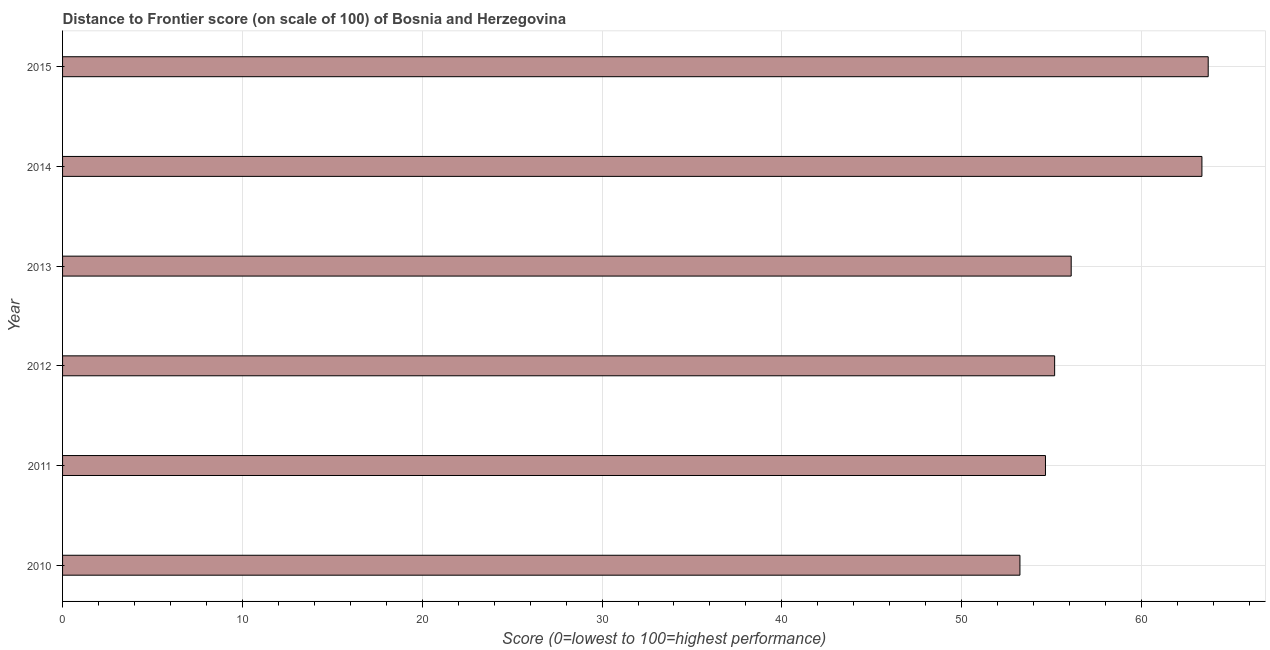Does the graph contain grids?
Make the answer very short. Yes. What is the title of the graph?
Offer a terse response. Distance to Frontier score (on scale of 100) of Bosnia and Herzegovina. What is the label or title of the X-axis?
Your answer should be compact. Score (0=lowest to 100=highest performance). What is the distance to frontier score in 2011?
Your answer should be compact. 54.66. Across all years, what is the maximum distance to frontier score?
Provide a succinct answer. 63.71. Across all years, what is the minimum distance to frontier score?
Provide a short and direct response. 53.24. In which year was the distance to frontier score maximum?
Offer a terse response. 2015. What is the sum of the distance to frontier score?
Keep it short and to the point. 346.23. What is the difference between the distance to frontier score in 2010 and 2015?
Your response must be concise. -10.47. What is the average distance to frontier score per year?
Your response must be concise. 57.7. What is the median distance to frontier score?
Give a very brief answer. 55.63. Do a majority of the years between 2014 and 2011 (inclusive) have distance to frontier score greater than 32 ?
Offer a very short reply. Yes. What is the ratio of the distance to frontier score in 2012 to that in 2015?
Your answer should be very brief. 0.87. Is the difference between the distance to frontier score in 2011 and 2013 greater than the difference between any two years?
Give a very brief answer. No. What is the difference between the highest and the lowest distance to frontier score?
Ensure brevity in your answer.  10.47. Are all the bars in the graph horizontal?
Your answer should be very brief. Yes. How many years are there in the graph?
Provide a short and direct response. 6. What is the Score (0=lowest to 100=highest performance) of 2010?
Provide a succinct answer. 53.24. What is the Score (0=lowest to 100=highest performance) in 2011?
Provide a short and direct response. 54.66. What is the Score (0=lowest to 100=highest performance) in 2012?
Give a very brief answer. 55.17. What is the Score (0=lowest to 100=highest performance) in 2013?
Keep it short and to the point. 56.09. What is the Score (0=lowest to 100=highest performance) in 2014?
Give a very brief answer. 63.36. What is the Score (0=lowest to 100=highest performance) of 2015?
Make the answer very short. 63.71. What is the difference between the Score (0=lowest to 100=highest performance) in 2010 and 2011?
Give a very brief answer. -1.42. What is the difference between the Score (0=lowest to 100=highest performance) in 2010 and 2012?
Keep it short and to the point. -1.93. What is the difference between the Score (0=lowest to 100=highest performance) in 2010 and 2013?
Keep it short and to the point. -2.85. What is the difference between the Score (0=lowest to 100=highest performance) in 2010 and 2014?
Offer a very short reply. -10.12. What is the difference between the Score (0=lowest to 100=highest performance) in 2010 and 2015?
Your answer should be very brief. -10.47. What is the difference between the Score (0=lowest to 100=highest performance) in 2011 and 2012?
Ensure brevity in your answer.  -0.51. What is the difference between the Score (0=lowest to 100=highest performance) in 2011 and 2013?
Keep it short and to the point. -1.43. What is the difference between the Score (0=lowest to 100=highest performance) in 2011 and 2014?
Your answer should be compact. -8.7. What is the difference between the Score (0=lowest to 100=highest performance) in 2011 and 2015?
Provide a succinct answer. -9.05. What is the difference between the Score (0=lowest to 100=highest performance) in 2012 and 2013?
Offer a very short reply. -0.92. What is the difference between the Score (0=lowest to 100=highest performance) in 2012 and 2014?
Your answer should be very brief. -8.19. What is the difference between the Score (0=lowest to 100=highest performance) in 2012 and 2015?
Your answer should be very brief. -8.54. What is the difference between the Score (0=lowest to 100=highest performance) in 2013 and 2014?
Provide a short and direct response. -7.27. What is the difference between the Score (0=lowest to 100=highest performance) in 2013 and 2015?
Make the answer very short. -7.62. What is the difference between the Score (0=lowest to 100=highest performance) in 2014 and 2015?
Give a very brief answer. -0.35. What is the ratio of the Score (0=lowest to 100=highest performance) in 2010 to that in 2011?
Ensure brevity in your answer.  0.97. What is the ratio of the Score (0=lowest to 100=highest performance) in 2010 to that in 2012?
Ensure brevity in your answer.  0.96. What is the ratio of the Score (0=lowest to 100=highest performance) in 2010 to that in 2013?
Keep it short and to the point. 0.95. What is the ratio of the Score (0=lowest to 100=highest performance) in 2010 to that in 2014?
Offer a very short reply. 0.84. What is the ratio of the Score (0=lowest to 100=highest performance) in 2010 to that in 2015?
Your answer should be very brief. 0.84. What is the ratio of the Score (0=lowest to 100=highest performance) in 2011 to that in 2014?
Give a very brief answer. 0.86. What is the ratio of the Score (0=lowest to 100=highest performance) in 2011 to that in 2015?
Keep it short and to the point. 0.86. What is the ratio of the Score (0=lowest to 100=highest performance) in 2012 to that in 2013?
Offer a terse response. 0.98. What is the ratio of the Score (0=lowest to 100=highest performance) in 2012 to that in 2014?
Make the answer very short. 0.87. What is the ratio of the Score (0=lowest to 100=highest performance) in 2012 to that in 2015?
Your answer should be compact. 0.87. What is the ratio of the Score (0=lowest to 100=highest performance) in 2013 to that in 2014?
Make the answer very short. 0.89. What is the ratio of the Score (0=lowest to 100=highest performance) in 2014 to that in 2015?
Your response must be concise. 0.99. 